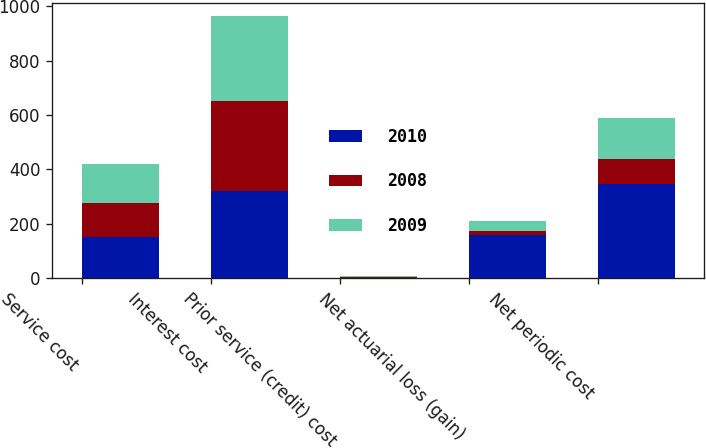Convert chart to OTSL. <chart><loc_0><loc_0><loc_500><loc_500><stacked_bar_chart><ecel><fcel>Service cost<fcel>Interest cost<fcel>Prior service (credit) cost<fcel>Net actuarial loss (gain)<fcel>Net periodic cost<nl><fcel>2010<fcel>150<fcel>320<fcel>2<fcel>160<fcel>345<nl><fcel>2008<fcel>125<fcel>331<fcel>3<fcel>15<fcel>92<nl><fcel>2009<fcel>145<fcel>313<fcel>2<fcel>37<fcel>153<nl></chart> 